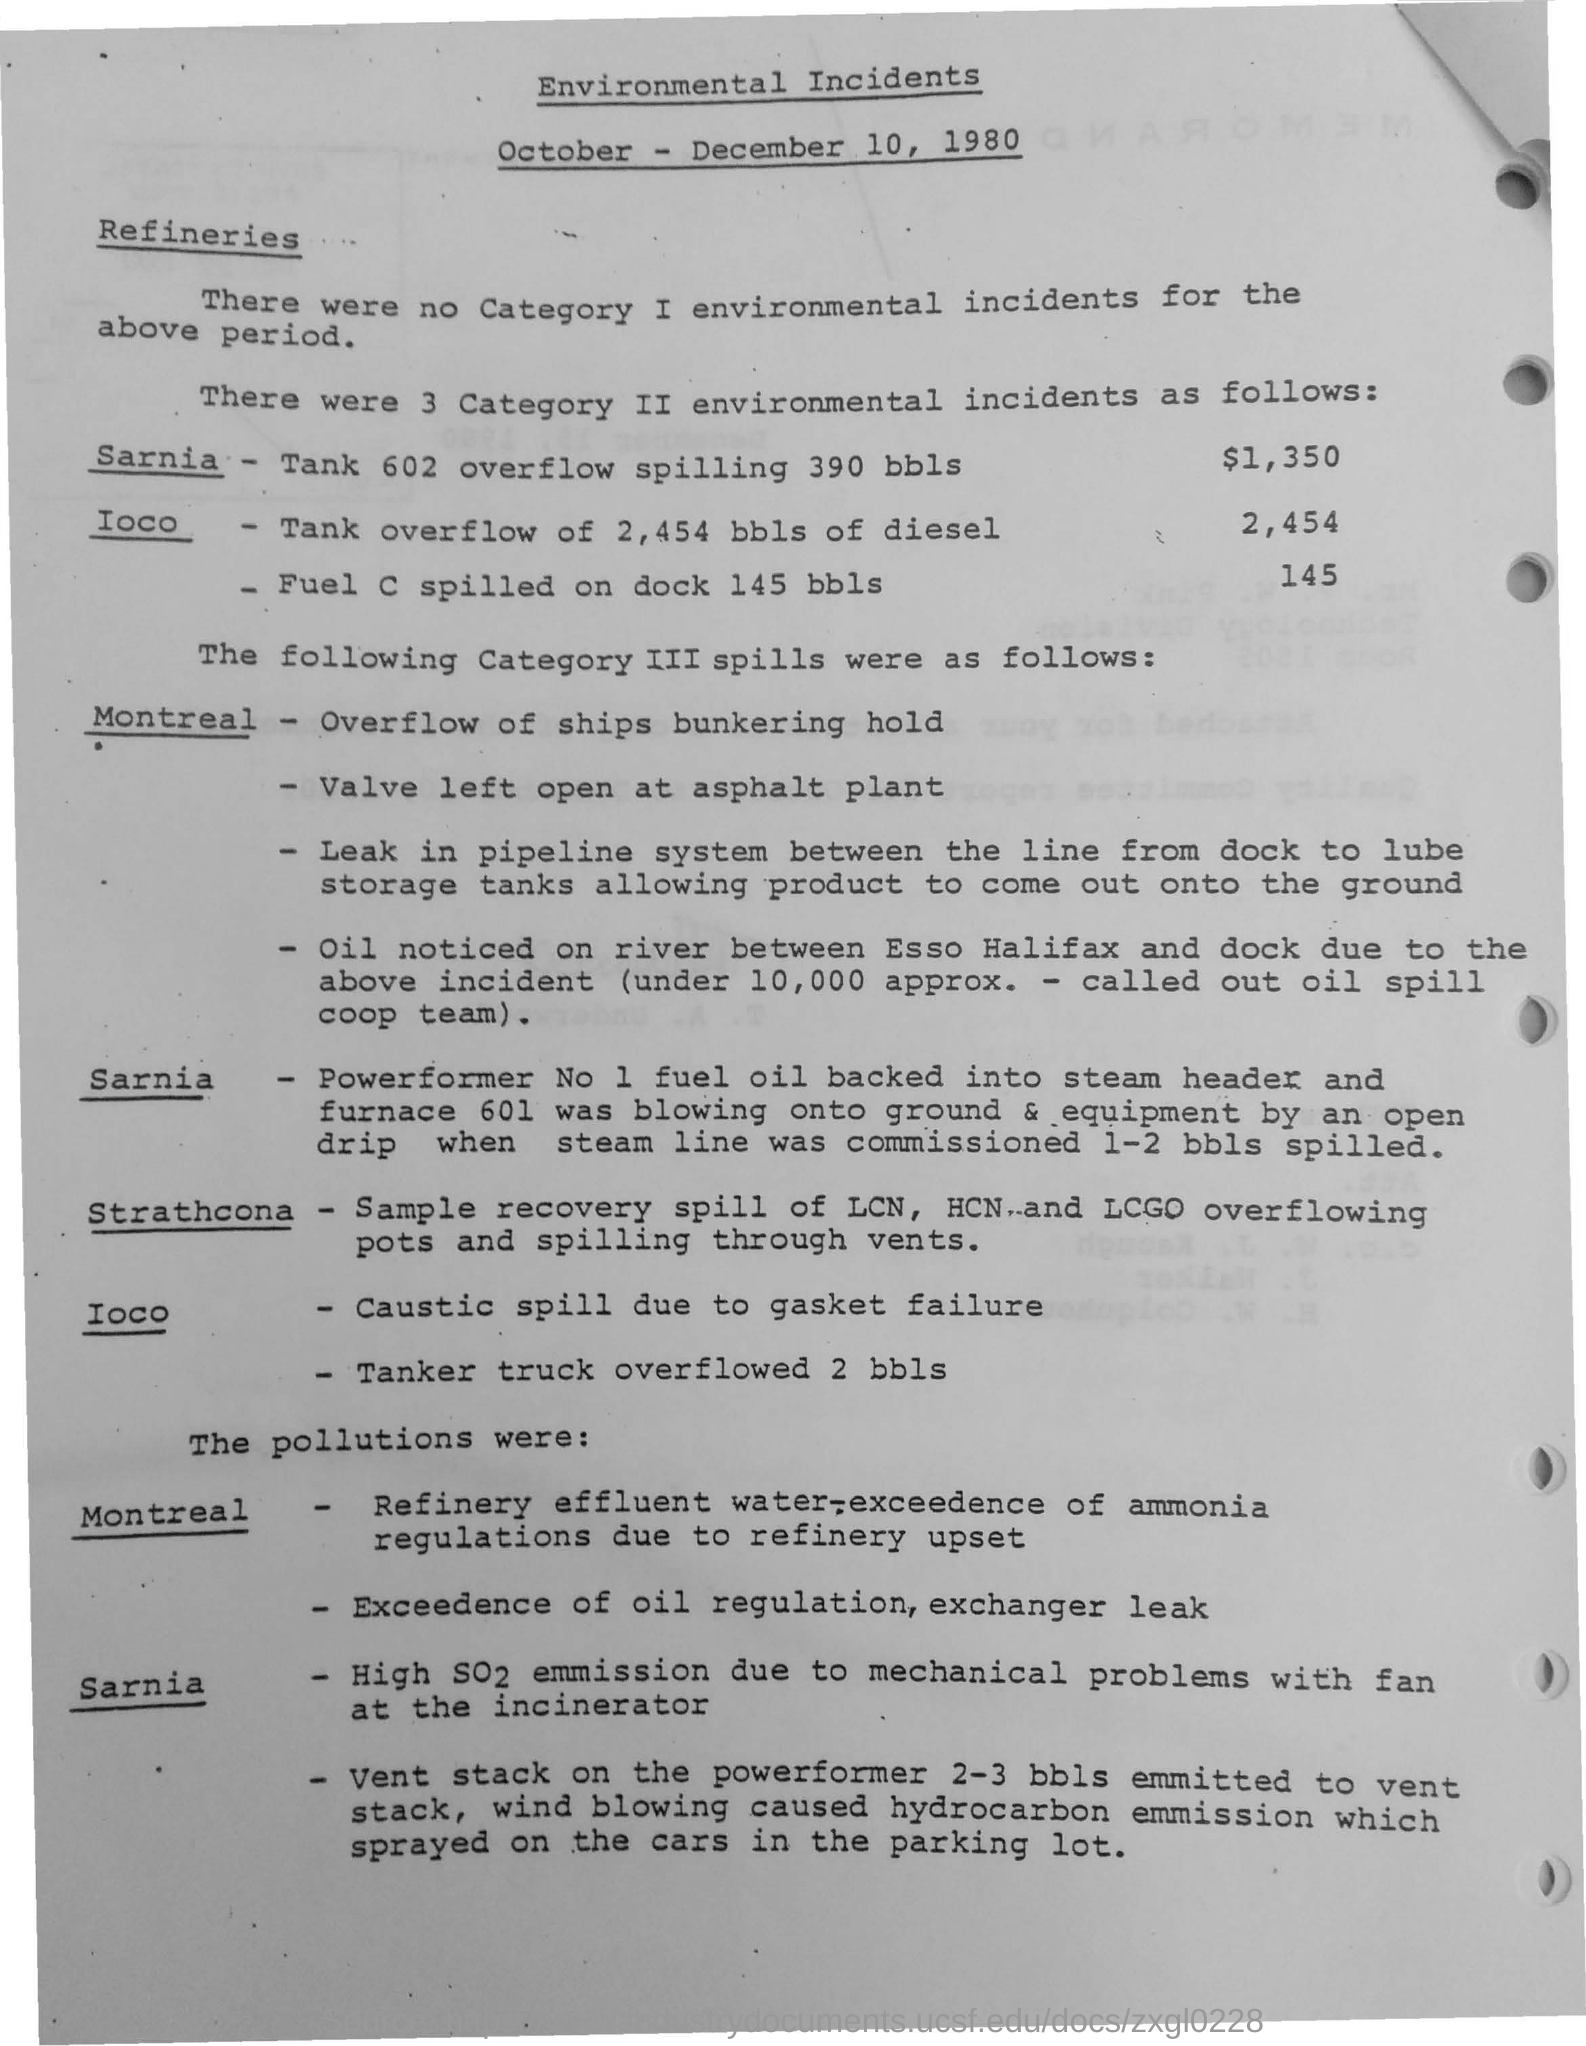Mention a couple of crucial points in this snapshot. Approximately 145 barrels of fuel were spilled on the dock. The incinerator experienced mechanical problems, resulting in high emissions of SO2 due to the high emission of which gas. Valve was left open at the asphalt plant, resulting in a hazardous situation. 